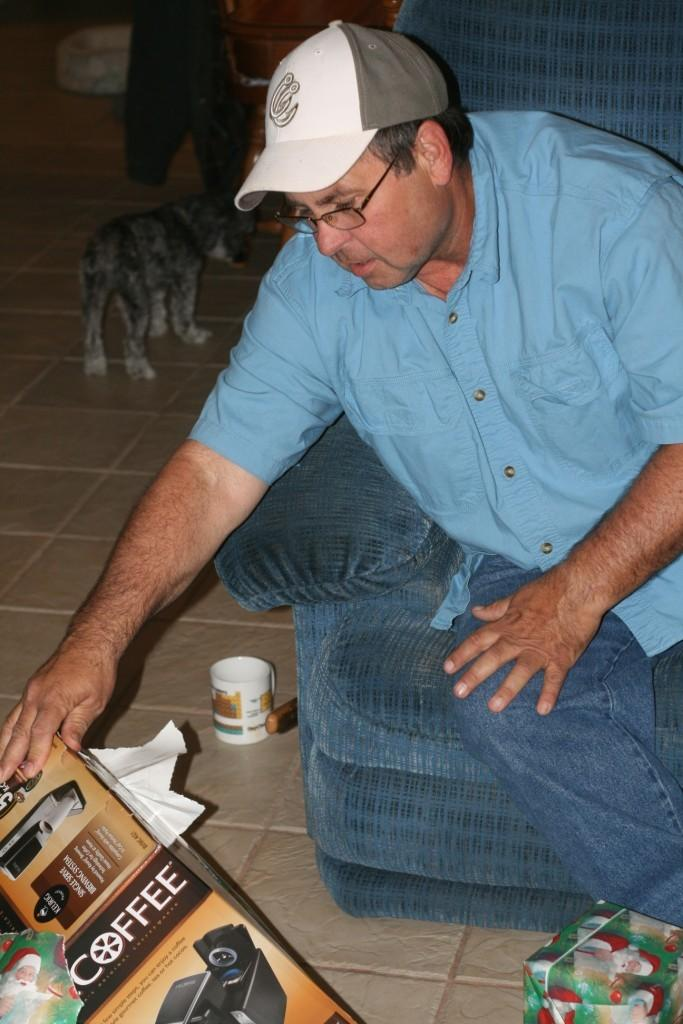What is the person in the image doing? The person is sitting in the image. Can you describe the person's clothing? The person is wearing a cap, a blue shirt, and jeans. What is on the left side of the image? There is a box and other objects on the left side of the image. Is there any animal visible in the image? Yes, there is a dog at the back of the image. What type of thunder can be heard in the image? There is no thunder present in the image; it is a still image with no sound. 